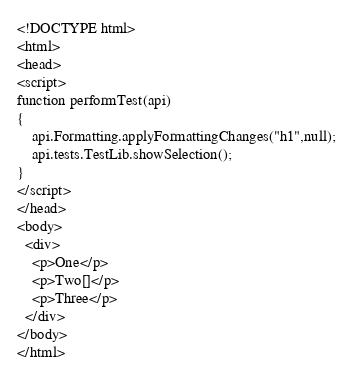<code> <loc_0><loc_0><loc_500><loc_500><_HTML_><!DOCTYPE html>
<html>
<head>
<script>
function performTest(api)
{
    api.Formatting.applyFormattingChanges("h1",null);
    api.tests.TestLib.showSelection();
}
</script>
</head>
<body>
  <div>
    <p>One</p>
    <p>Two[]</p>
    <p>Three</p>
  </div>
</body>
</html>
</code> 